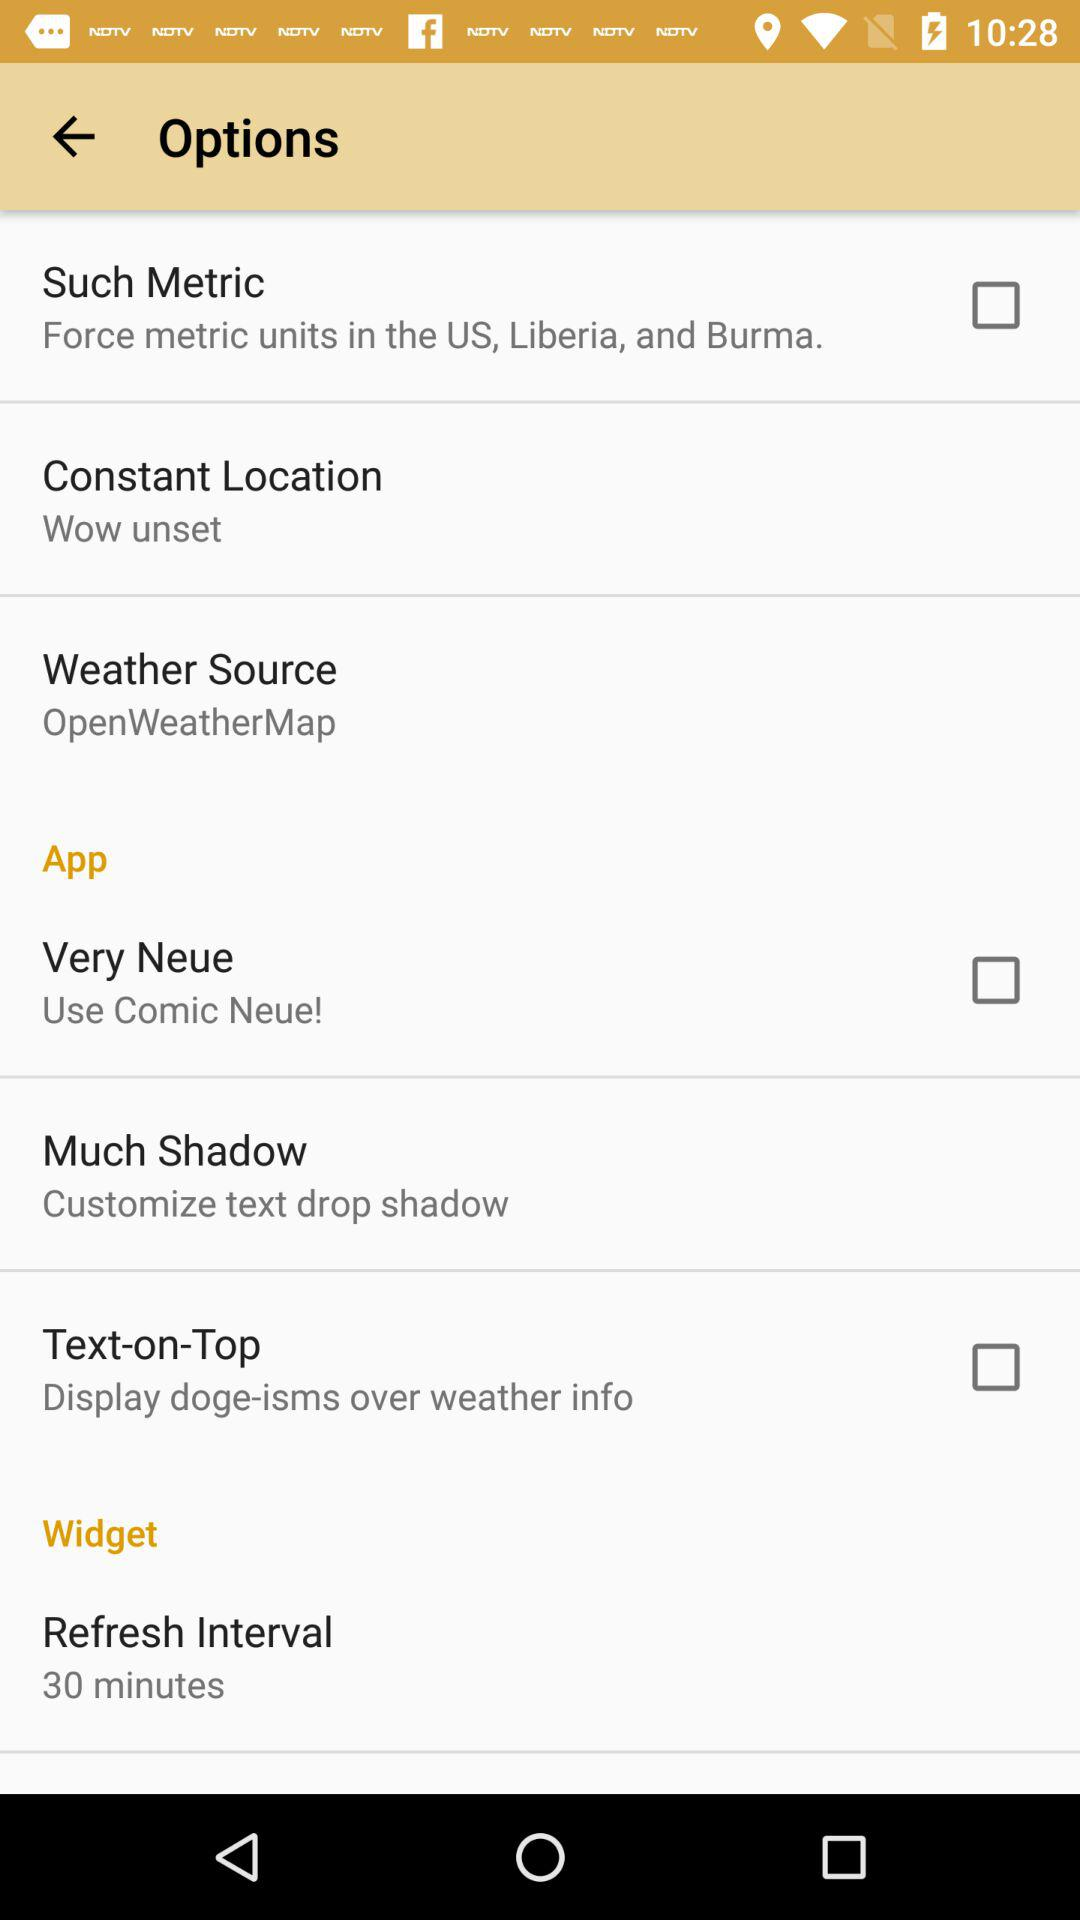What is the status of the text on top? The status is "off". 